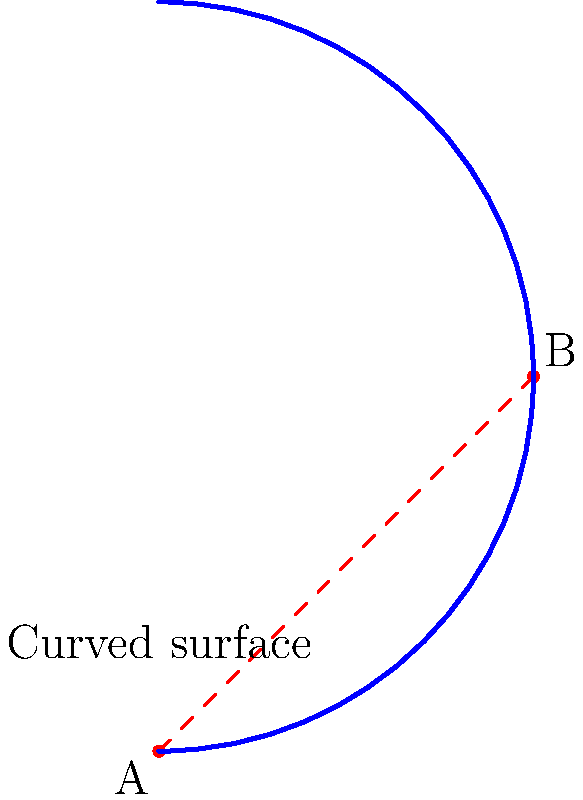On a curved tennis court surface represented by the blue arc, what is the shortest path between points A and B? How does this compare to the straight line (dashed red) connecting the two points? To understand the shortest path between two points on a curved surface, we need to consider the principles of non-Euclidean geometry:

1. In Euclidean geometry (flat surfaces), the shortest path between two points is always a straight line.

2. However, on curved surfaces, the shortest path is called a geodesic. This is the path that a ball would follow if rolled from one point to another without any external forces acting on it.

3. For a spherical surface (which this curved court approximates locally):
   a. The geodesic is a great circle, which is the intersection of the sphere with a plane passing through the center of the sphere and both points.
   b. This path appears as an arc on the surface.

4. In this case, the shortest path between A and B would follow the blue curve, which represents the geodesic on this curved surface.

5. The dashed red line represents the straight-line distance "through" the surface, which is shorter in Euclidean space but not actually traversable on the curved surface.

6. The difference between the geodesic (blue arc) and the Euclidean straight line (dashed red) increases with:
   a. The curvature of the surface
   b. The distance between the points

7. In tennis strategy, understanding this concept could be crucial when anticipating ball trajectories on courts with subtle curvatures or when playing on non-standard surfaces.
Answer: The geodesic along the blue arc 